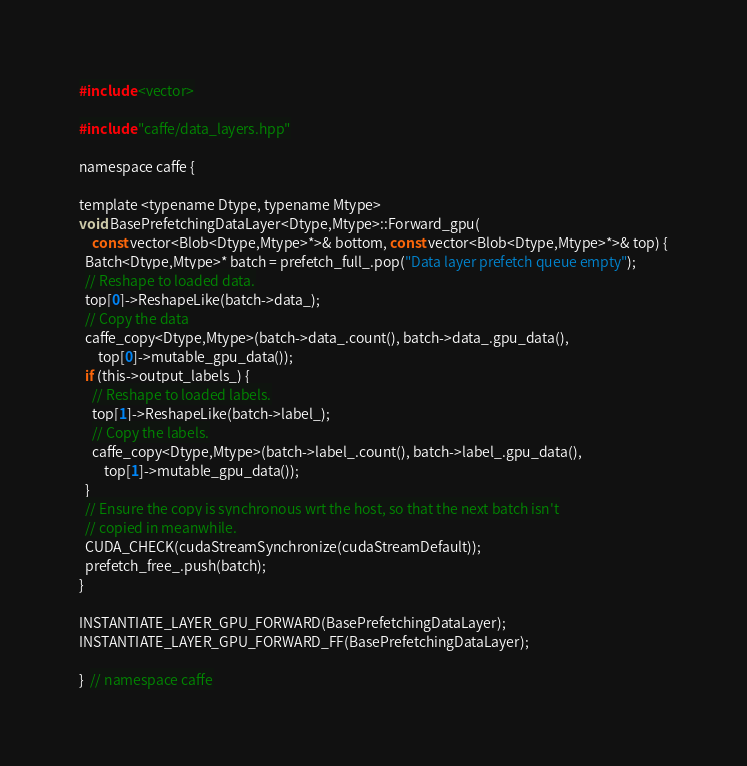Convert code to text. <code><loc_0><loc_0><loc_500><loc_500><_Cuda_>#include <vector>

#include "caffe/data_layers.hpp"

namespace caffe {

template <typename Dtype, typename Mtype>
void BasePrefetchingDataLayer<Dtype,Mtype>::Forward_gpu(
    const vector<Blob<Dtype,Mtype>*>& bottom, const vector<Blob<Dtype,Mtype>*>& top) {
  Batch<Dtype,Mtype>* batch = prefetch_full_.pop("Data layer prefetch queue empty");
  // Reshape to loaded data.
  top[0]->ReshapeLike(batch->data_);
  // Copy the data
  caffe_copy<Dtype,Mtype>(batch->data_.count(), batch->data_.gpu_data(),
      top[0]->mutable_gpu_data());
  if (this->output_labels_) {
    // Reshape to loaded labels.
    top[1]->ReshapeLike(batch->label_);
    // Copy the labels.
    caffe_copy<Dtype,Mtype>(batch->label_.count(), batch->label_.gpu_data(),
        top[1]->mutable_gpu_data());
  }
  // Ensure the copy is synchronous wrt the host, so that the next batch isn't
  // copied in meanwhile.
  CUDA_CHECK(cudaStreamSynchronize(cudaStreamDefault));
  prefetch_free_.push(batch);
}

INSTANTIATE_LAYER_GPU_FORWARD(BasePrefetchingDataLayer);
INSTANTIATE_LAYER_GPU_FORWARD_FF(BasePrefetchingDataLayer);

}  // namespace caffe
</code> 